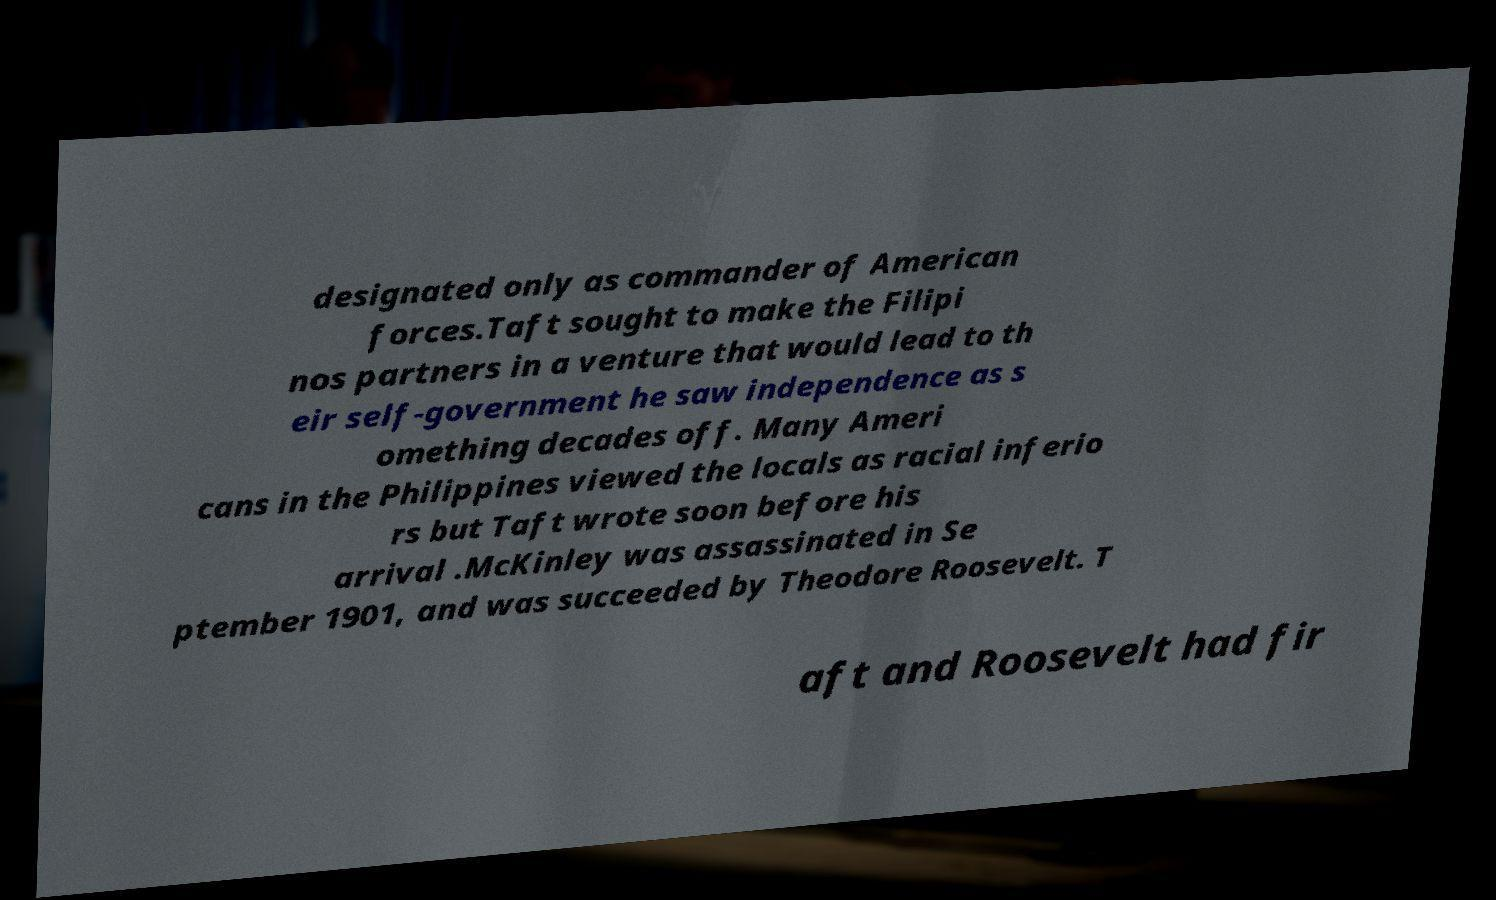Could you assist in decoding the text presented in this image and type it out clearly? designated only as commander of American forces.Taft sought to make the Filipi nos partners in a venture that would lead to th eir self-government he saw independence as s omething decades off. Many Ameri cans in the Philippines viewed the locals as racial inferio rs but Taft wrote soon before his arrival .McKinley was assassinated in Se ptember 1901, and was succeeded by Theodore Roosevelt. T aft and Roosevelt had fir 